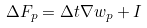Convert formula to latex. <formula><loc_0><loc_0><loc_500><loc_500>\Delta F _ { p } = \Delta t \nabla w _ { p } + I</formula> 